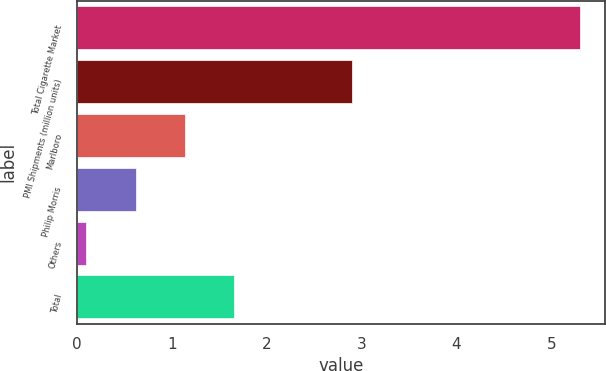<chart> <loc_0><loc_0><loc_500><loc_500><bar_chart><fcel>Total Cigarette Market<fcel>PMI Shipments (million units)<fcel>Marlboro<fcel>Philip Morris<fcel>Others<fcel>Total<nl><fcel>5.3<fcel>2.9<fcel>1.14<fcel>0.62<fcel>0.1<fcel>1.66<nl></chart> 